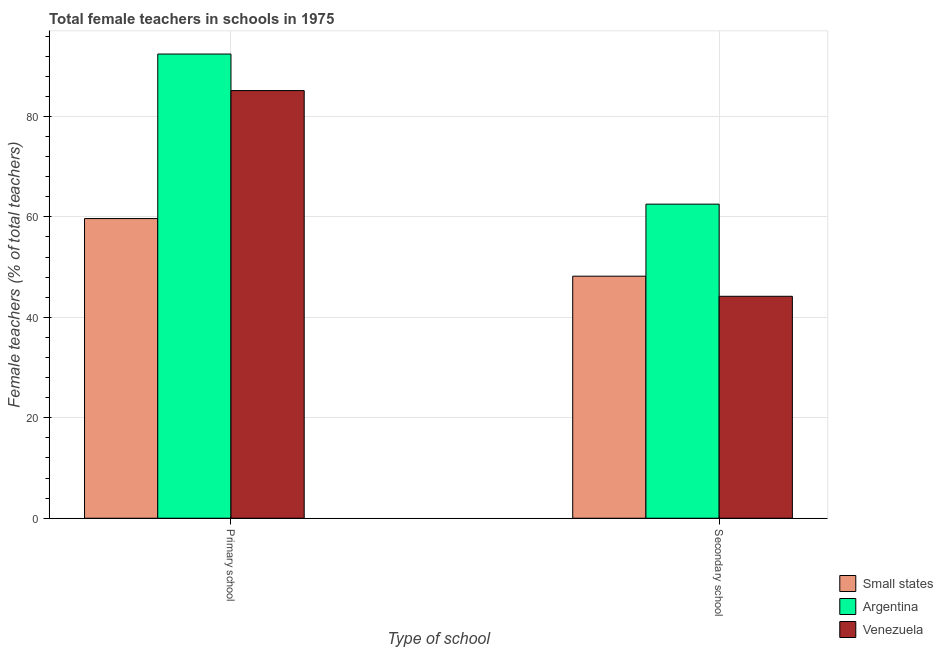How many different coloured bars are there?
Make the answer very short. 3. Are the number of bars on each tick of the X-axis equal?
Your answer should be very brief. Yes. What is the label of the 1st group of bars from the left?
Offer a terse response. Primary school. What is the percentage of female teachers in primary schools in Venezuela?
Offer a very short reply. 85.14. Across all countries, what is the maximum percentage of female teachers in primary schools?
Offer a very short reply. 92.42. Across all countries, what is the minimum percentage of female teachers in secondary schools?
Ensure brevity in your answer.  44.19. In which country was the percentage of female teachers in primary schools maximum?
Make the answer very short. Argentina. In which country was the percentage of female teachers in secondary schools minimum?
Give a very brief answer. Venezuela. What is the total percentage of female teachers in secondary schools in the graph?
Ensure brevity in your answer.  154.91. What is the difference between the percentage of female teachers in primary schools in Small states and that in Venezuela?
Offer a very short reply. -25.48. What is the difference between the percentage of female teachers in primary schools in Venezuela and the percentage of female teachers in secondary schools in Argentina?
Offer a very short reply. 22.61. What is the average percentage of female teachers in secondary schools per country?
Give a very brief answer. 51.64. What is the difference between the percentage of female teachers in secondary schools and percentage of female teachers in primary schools in Argentina?
Provide a succinct answer. -29.89. What is the ratio of the percentage of female teachers in primary schools in Argentina to that in Venezuela?
Provide a succinct answer. 1.09. What does the 3rd bar from the left in Primary school represents?
Provide a succinct answer. Venezuela. What does the 2nd bar from the right in Primary school represents?
Give a very brief answer. Argentina. How many bars are there?
Make the answer very short. 6. Are all the bars in the graph horizontal?
Your answer should be compact. No. Does the graph contain grids?
Provide a succinct answer. Yes. Where does the legend appear in the graph?
Keep it short and to the point. Bottom right. How many legend labels are there?
Your answer should be very brief. 3. What is the title of the graph?
Your answer should be very brief. Total female teachers in schools in 1975. Does "Eritrea" appear as one of the legend labels in the graph?
Give a very brief answer. No. What is the label or title of the X-axis?
Offer a very short reply. Type of school. What is the label or title of the Y-axis?
Offer a very short reply. Female teachers (% of total teachers). What is the Female teachers (% of total teachers) in Small states in Primary school?
Keep it short and to the point. 59.66. What is the Female teachers (% of total teachers) of Argentina in Primary school?
Keep it short and to the point. 92.42. What is the Female teachers (% of total teachers) in Venezuela in Primary school?
Your answer should be very brief. 85.14. What is the Female teachers (% of total teachers) in Small states in Secondary school?
Offer a very short reply. 48.19. What is the Female teachers (% of total teachers) of Argentina in Secondary school?
Give a very brief answer. 62.53. What is the Female teachers (% of total teachers) in Venezuela in Secondary school?
Provide a succinct answer. 44.19. Across all Type of school, what is the maximum Female teachers (% of total teachers) of Small states?
Keep it short and to the point. 59.66. Across all Type of school, what is the maximum Female teachers (% of total teachers) of Argentina?
Your response must be concise. 92.42. Across all Type of school, what is the maximum Female teachers (% of total teachers) in Venezuela?
Keep it short and to the point. 85.14. Across all Type of school, what is the minimum Female teachers (% of total teachers) of Small states?
Provide a succinct answer. 48.19. Across all Type of school, what is the minimum Female teachers (% of total teachers) in Argentina?
Your response must be concise. 62.53. Across all Type of school, what is the minimum Female teachers (% of total teachers) of Venezuela?
Your response must be concise. 44.19. What is the total Female teachers (% of total teachers) of Small states in the graph?
Provide a short and direct response. 107.85. What is the total Female teachers (% of total teachers) of Argentina in the graph?
Provide a succinct answer. 154.95. What is the total Female teachers (% of total teachers) of Venezuela in the graph?
Make the answer very short. 129.33. What is the difference between the Female teachers (% of total teachers) of Small states in Primary school and that in Secondary school?
Your response must be concise. 11.47. What is the difference between the Female teachers (% of total teachers) in Argentina in Primary school and that in Secondary school?
Your answer should be compact. 29.89. What is the difference between the Female teachers (% of total teachers) of Venezuela in Primary school and that in Secondary school?
Your answer should be compact. 40.95. What is the difference between the Female teachers (% of total teachers) of Small states in Primary school and the Female teachers (% of total teachers) of Argentina in Secondary school?
Keep it short and to the point. -2.87. What is the difference between the Female teachers (% of total teachers) in Small states in Primary school and the Female teachers (% of total teachers) in Venezuela in Secondary school?
Your answer should be compact. 15.47. What is the difference between the Female teachers (% of total teachers) in Argentina in Primary school and the Female teachers (% of total teachers) in Venezuela in Secondary school?
Provide a succinct answer. 48.23. What is the average Female teachers (% of total teachers) of Small states per Type of school?
Provide a short and direct response. 53.93. What is the average Female teachers (% of total teachers) of Argentina per Type of school?
Provide a succinct answer. 77.48. What is the average Female teachers (% of total teachers) in Venezuela per Type of school?
Offer a terse response. 64.66. What is the difference between the Female teachers (% of total teachers) in Small states and Female teachers (% of total teachers) in Argentina in Primary school?
Make the answer very short. -32.76. What is the difference between the Female teachers (% of total teachers) of Small states and Female teachers (% of total teachers) of Venezuela in Primary school?
Provide a short and direct response. -25.48. What is the difference between the Female teachers (% of total teachers) in Argentina and Female teachers (% of total teachers) in Venezuela in Primary school?
Your answer should be very brief. 7.28. What is the difference between the Female teachers (% of total teachers) of Small states and Female teachers (% of total teachers) of Argentina in Secondary school?
Ensure brevity in your answer.  -14.34. What is the difference between the Female teachers (% of total teachers) in Small states and Female teachers (% of total teachers) in Venezuela in Secondary school?
Offer a terse response. 4. What is the difference between the Female teachers (% of total teachers) in Argentina and Female teachers (% of total teachers) in Venezuela in Secondary school?
Provide a succinct answer. 18.35. What is the ratio of the Female teachers (% of total teachers) of Small states in Primary school to that in Secondary school?
Your answer should be compact. 1.24. What is the ratio of the Female teachers (% of total teachers) in Argentina in Primary school to that in Secondary school?
Make the answer very short. 1.48. What is the ratio of the Female teachers (% of total teachers) in Venezuela in Primary school to that in Secondary school?
Give a very brief answer. 1.93. What is the difference between the highest and the second highest Female teachers (% of total teachers) of Small states?
Give a very brief answer. 11.47. What is the difference between the highest and the second highest Female teachers (% of total teachers) of Argentina?
Keep it short and to the point. 29.89. What is the difference between the highest and the second highest Female teachers (% of total teachers) in Venezuela?
Your answer should be compact. 40.95. What is the difference between the highest and the lowest Female teachers (% of total teachers) in Small states?
Your response must be concise. 11.47. What is the difference between the highest and the lowest Female teachers (% of total teachers) in Argentina?
Your response must be concise. 29.89. What is the difference between the highest and the lowest Female teachers (% of total teachers) of Venezuela?
Your response must be concise. 40.95. 